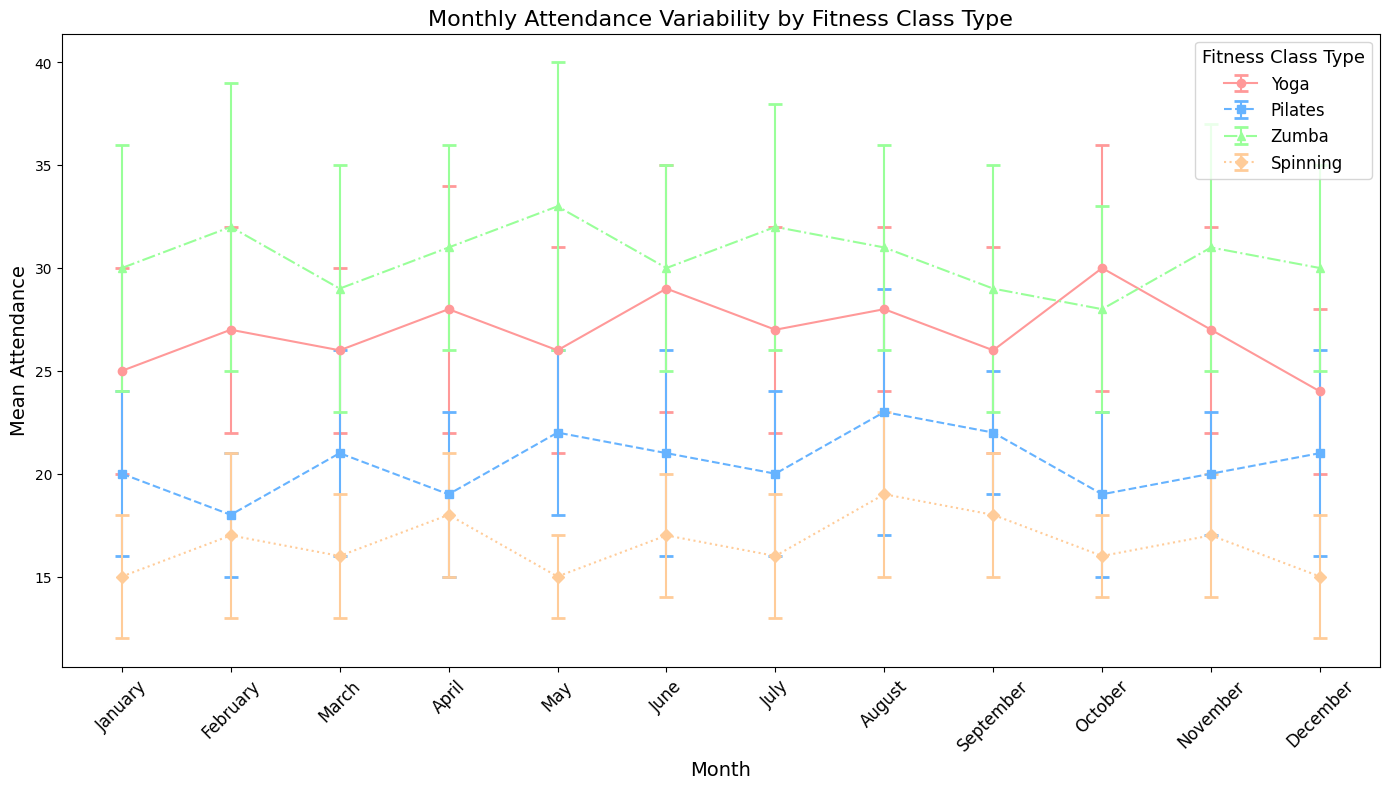Which month has the highest mean attendance for Zumba classes? Look at the Zumba error bars and find the month with the highest mean attendance value by comparing the height of the error bars.
Answer: May Between March and July, which Pilates class has the lowest mean attendance? Compare the mean attendance values of Pilates classes from March to July, and identify the lowest value.
Answer: June What is the average mean attendance for Yoga classes from January to June? Sum the mean attendance values for Yoga from January (25), February (27), March (26), April (28), May (26), and June (29); then divide by the number of months (6). (25 + 27 + 26 + 28 + 26 + 29) / 6 = 161 / 6.
Answer: Approximately 26.8 In December, which class type has the smallest confidence interval for attendance? Compare all confidence interval ranges for the class types in December by measuring the distances between the upper and lower bounds (Yoga: 24 to 28, Pilates: 21 to 26, Zumba: 30 to 35, Spinning: 15 to 18) and select the smallest one. The interval is the shortest for Spinning with a range of 3.
Answer: Spinning During which month is the mean attendance for Spinning classes closest to the upper confidence interval for Yoga classes? Examine the upper confidence interval for Yoga in each month and find the month where the Spinning mean value is closest. By comparing, we find that April's Yoga upper interval is 34, and Spinning mean is 18, which is closest.
Answer: April How does the mean attendance of Pilates in October compare to Zumba in the same month? Look at the error bars for October and compare the mean attendance for Pilates (19) and Zumba (28).
Answer: Zumba is higher Which fitness class type shows the least variability in attendance over the year? Identify the class type with the smallest standard deviation in mean attendance values by visually comparing the confidence interval ranges (Narrowest bars indicate less variability).
Answer: Spinning In August, what is the difference between the upper confidence interval for Yoga and the lower confidence interval for Zumba? Subtract the lower bound of Zumba's confidence interval from the upper bound of Yoga's confidence interval (32 - 26).
Answer: 6 